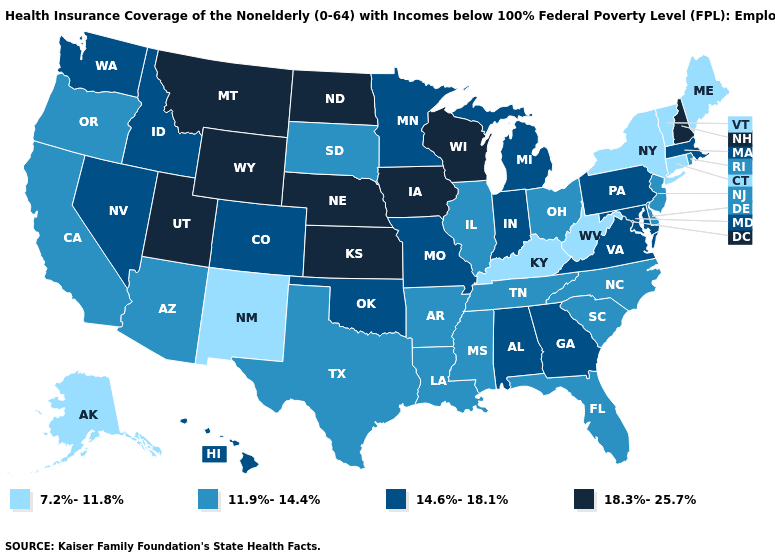Name the states that have a value in the range 18.3%-25.7%?
Be succinct. Iowa, Kansas, Montana, Nebraska, New Hampshire, North Dakota, Utah, Wisconsin, Wyoming. What is the value of Vermont?
Keep it brief. 7.2%-11.8%. Name the states that have a value in the range 7.2%-11.8%?
Quick response, please. Alaska, Connecticut, Kentucky, Maine, New Mexico, New York, Vermont, West Virginia. Does Kansas have a lower value than Montana?
Answer briefly. No. Which states have the lowest value in the MidWest?
Answer briefly. Illinois, Ohio, South Dakota. Which states have the lowest value in the USA?
Write a very short answer. Alaska, Connecticut, Kentucky, Maine, New Mexico, New York, Vermont, West Virginia. Name the states that have a value in the range 14.6%-18.1%?
Write a very short answer. Alabama, Colorado, Georgia, Hawaii, Idaho, Indiana, Maryland, Massachusetts, Michigan, Minnesota, Missouri, Nevada, Oklahoma, Pennsylvania, Virginia, Washington. Name the states that have a value in the range 18.3%-25.7%?
Answer briefly. Iowa, Kansas, Montana, Nebraska, New Hampshire, North Dakota, Utah, Wisconsin, Wyoming. Name the states that have a value in the range 14.6%-18.1%?
Be succinct. Alabama, Colorado, Georgia, Hawaii, Idaho, Indiana, Maryland, Massachusetts, Michigan, Minnesota, Missouri, Nevada, Oklahoma, Pennsylvania, Virginia, Washington. Does the map have missing data?
Write a very short answer. No. Name the states that have a value in the range 14.6%-18.1%?
Short answer required. Alabama, Colorado, Georgia, Hawaii, Idaho, Indiana, Maryland, Massachusetts, Michigan, Minnesota, Missouri, Nevada, Oklahoma, Pennsylvania, Virginia, Washington. What is the lowest value in the USA?
Keep it brief. 7.2%-11.8%. Does Arizona have a higher value than Vermont?
Short answer required. Yes. Name the states that have a value in the range 7.2%-11.8%?
Write a very short answer. Alaska, Connecticut, Kentucky, Maine, New Mexico, New York, Vermont, West Virginia. 